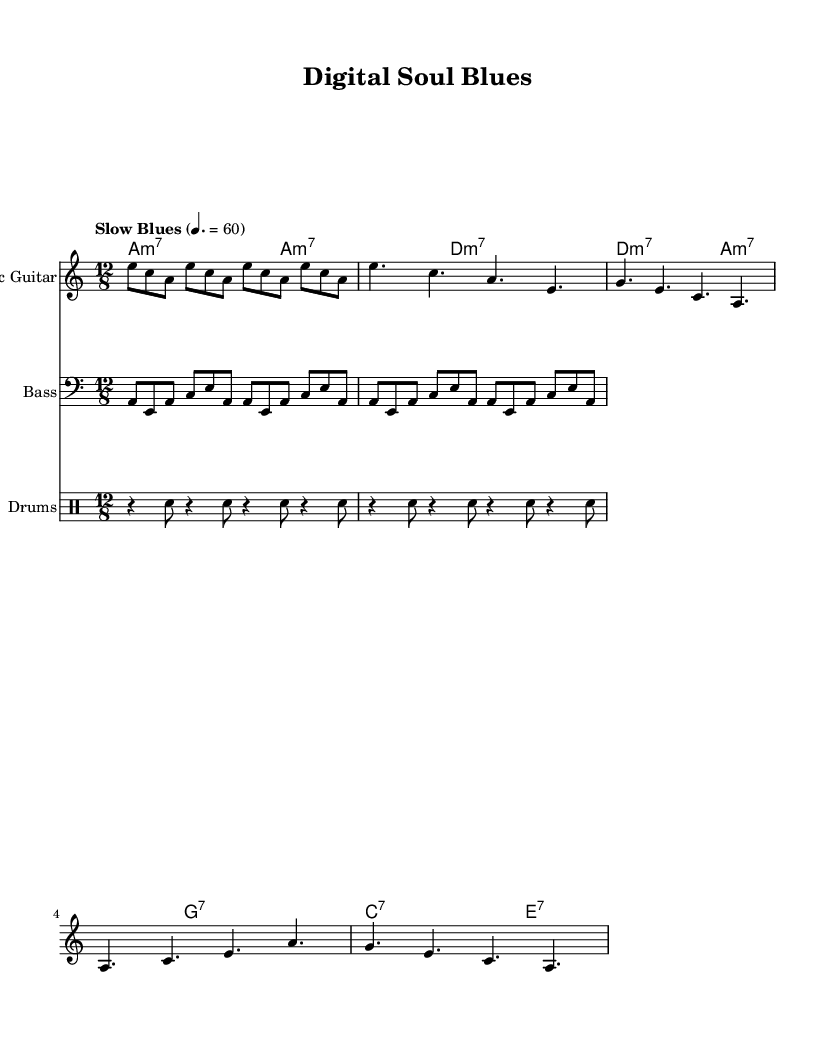What is the key signature of this music? The key signature appears at the beginning of the sheet music and indicates that it is in A minor, which has no sharps or flats.
Answer: A minor What is the time signature of this music? The time signature is found at the beginning of the piece and shows a 12/8 pattern, meaning each measure has twelve eighth notes, emphasizing a triplet feel typical of blues music.
Answer: 12/8 What is the tempo marking for this piece? The tempo marking, indicated in the score, specifies the speed of the music. It is marked as "Slow Blues" with a metronome marking of 60 beats per minute.
Answer: Slow Blues, 60 How many measures are in the chorus section? The chorus section is visually identified in the sheet music after the first verse and is repeated. The sheet music indicates it has four measures.
Answer: Four measures Which instrument plays the bass line? The score specifies that the bass line is played by the instrument labeled "Bass," which is indicated with a clef symbol identifying its part.
Answer: Bass What chord is played in the first measure? The chord names are indicated above the staves, and in the first measure, the chord played is A minor 7, as represented by the notation.
Answer: A minor 7 What is the primary genre of this piece? The title and the style indicated in the score, along with the blues structure and use of electric instruments, classify the piece as Electric Blues.
Answer: Electric Blues 